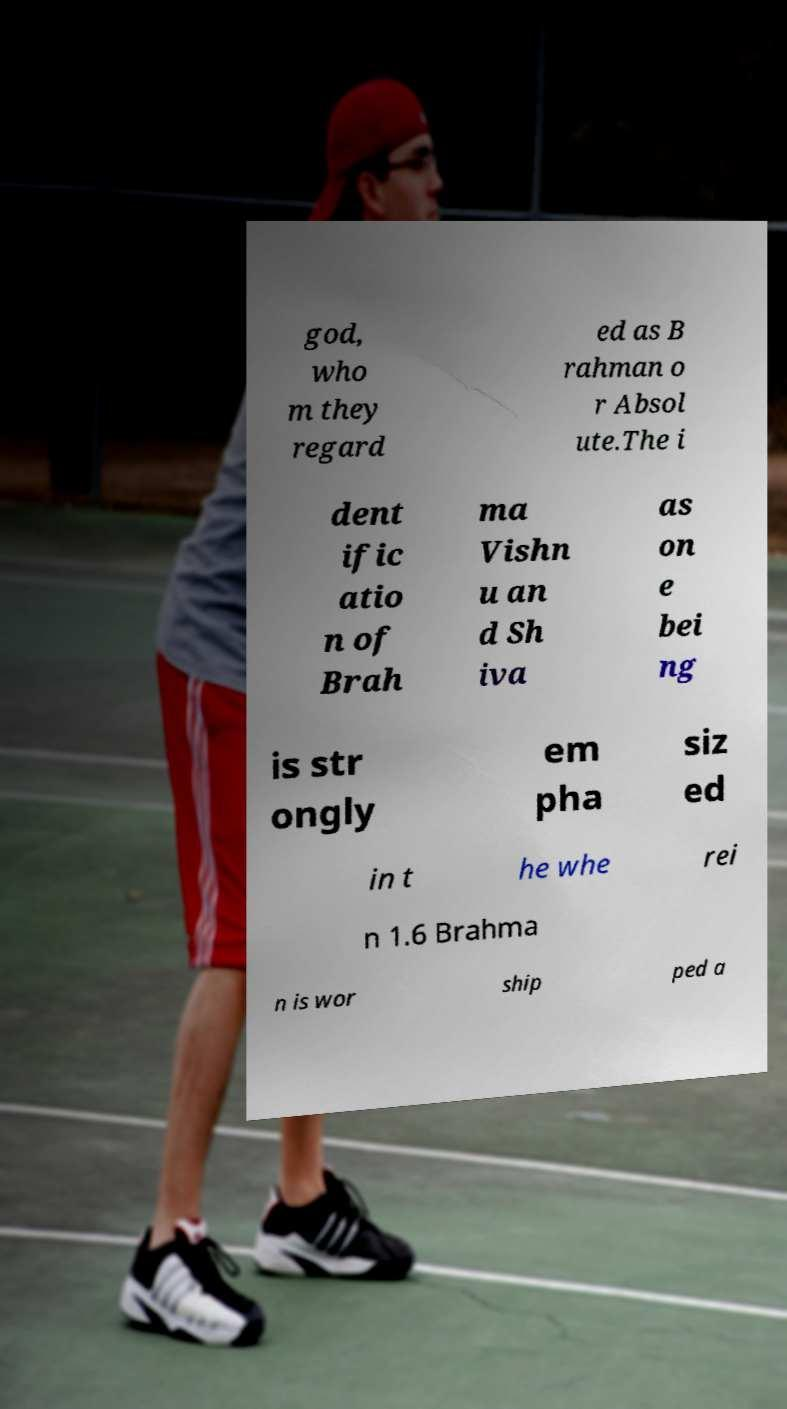What messages or text are displayed in this image? I need them in a readable, typed format. god, who m they regard ed as B rahman o r Absol ute.The i dent ific atio n of Brah ma Vishn u an d Sh iva as on e bei ng is str ongly em pha siz ed in t he whe rei n 1.6 Brahma n is wor ship ped a 